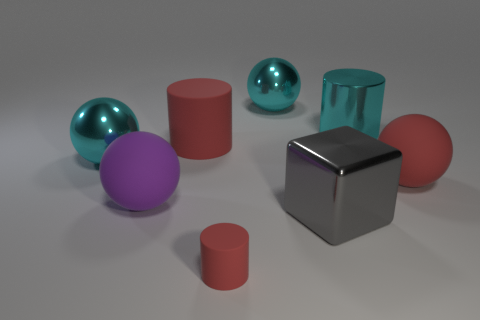Do the red thing to the right of the tiny matte cylinder and the gray block have the same material?
Give a very brief answer. No. How many purple objects have the same size as the purple matte sphere?
Ensure brevity in your answer.  0. Are there more big matte cylinders to the right of the tiny red object than big purple objects that are in front of the big gray object?
Keep it short and to the point. No. Are there any blue things that have the same shape as the tiny red matte object?
Give a very brief answer. No. What is the size of the matte ball that is left of the red matte object that is right of the large gray block?
Ensure brevity in your answer.  Large. What shape is the large cyan thing to the left of the big red rubber object on the left side of the large matte object that is to the right of the small rubber cylinder?
Provide a succinct answer. Sphere. The red ball that is made of the same material as the purple ball is what size?
Keep it short and to the point. Large. Are there more large cyan matte things than rubber balls?
Your answer should be compact. No. There is a red cylinder that is the same size as the gray cube; what is its material?
Make the answer very short. Rubber. Does the cyan shiny object that is on the right side of the gray metallic cube have the same size as the tiny rubber cylinder?
Ensure brevity in your answer.  No. 